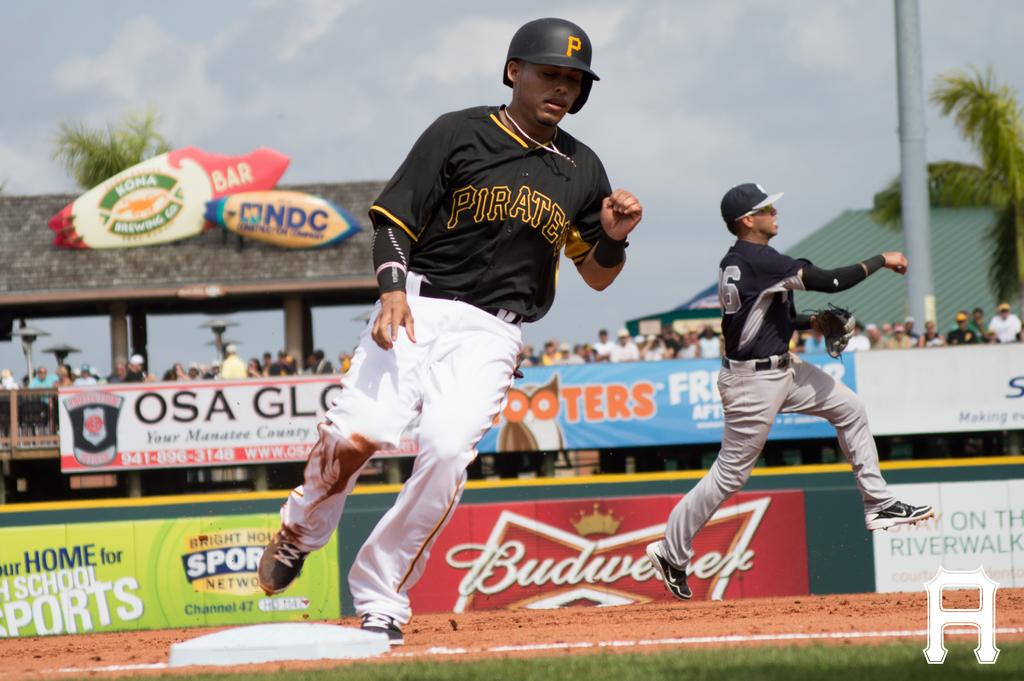<image>
Provide a brief description of the given image. A Budweiser ad can be seen on a baseball field. 